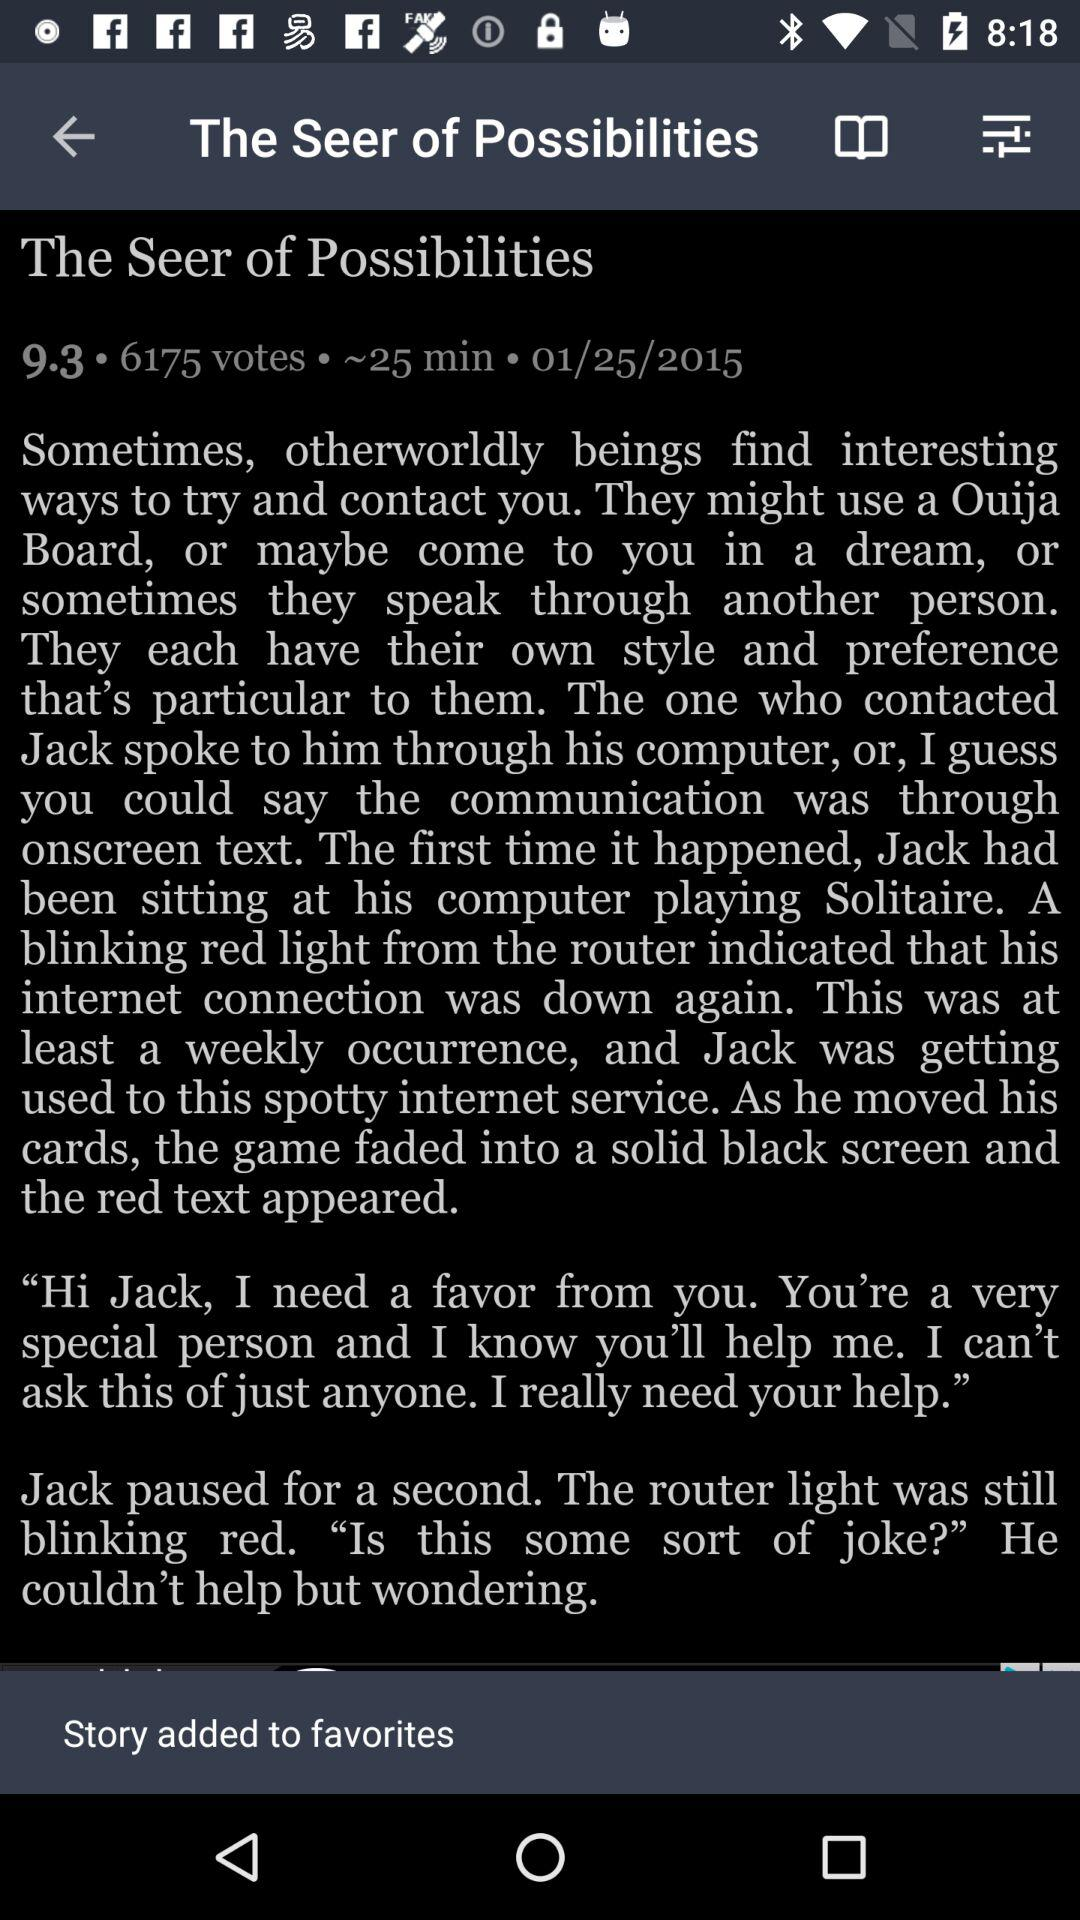What is the date? The date is January 25, 2015. 